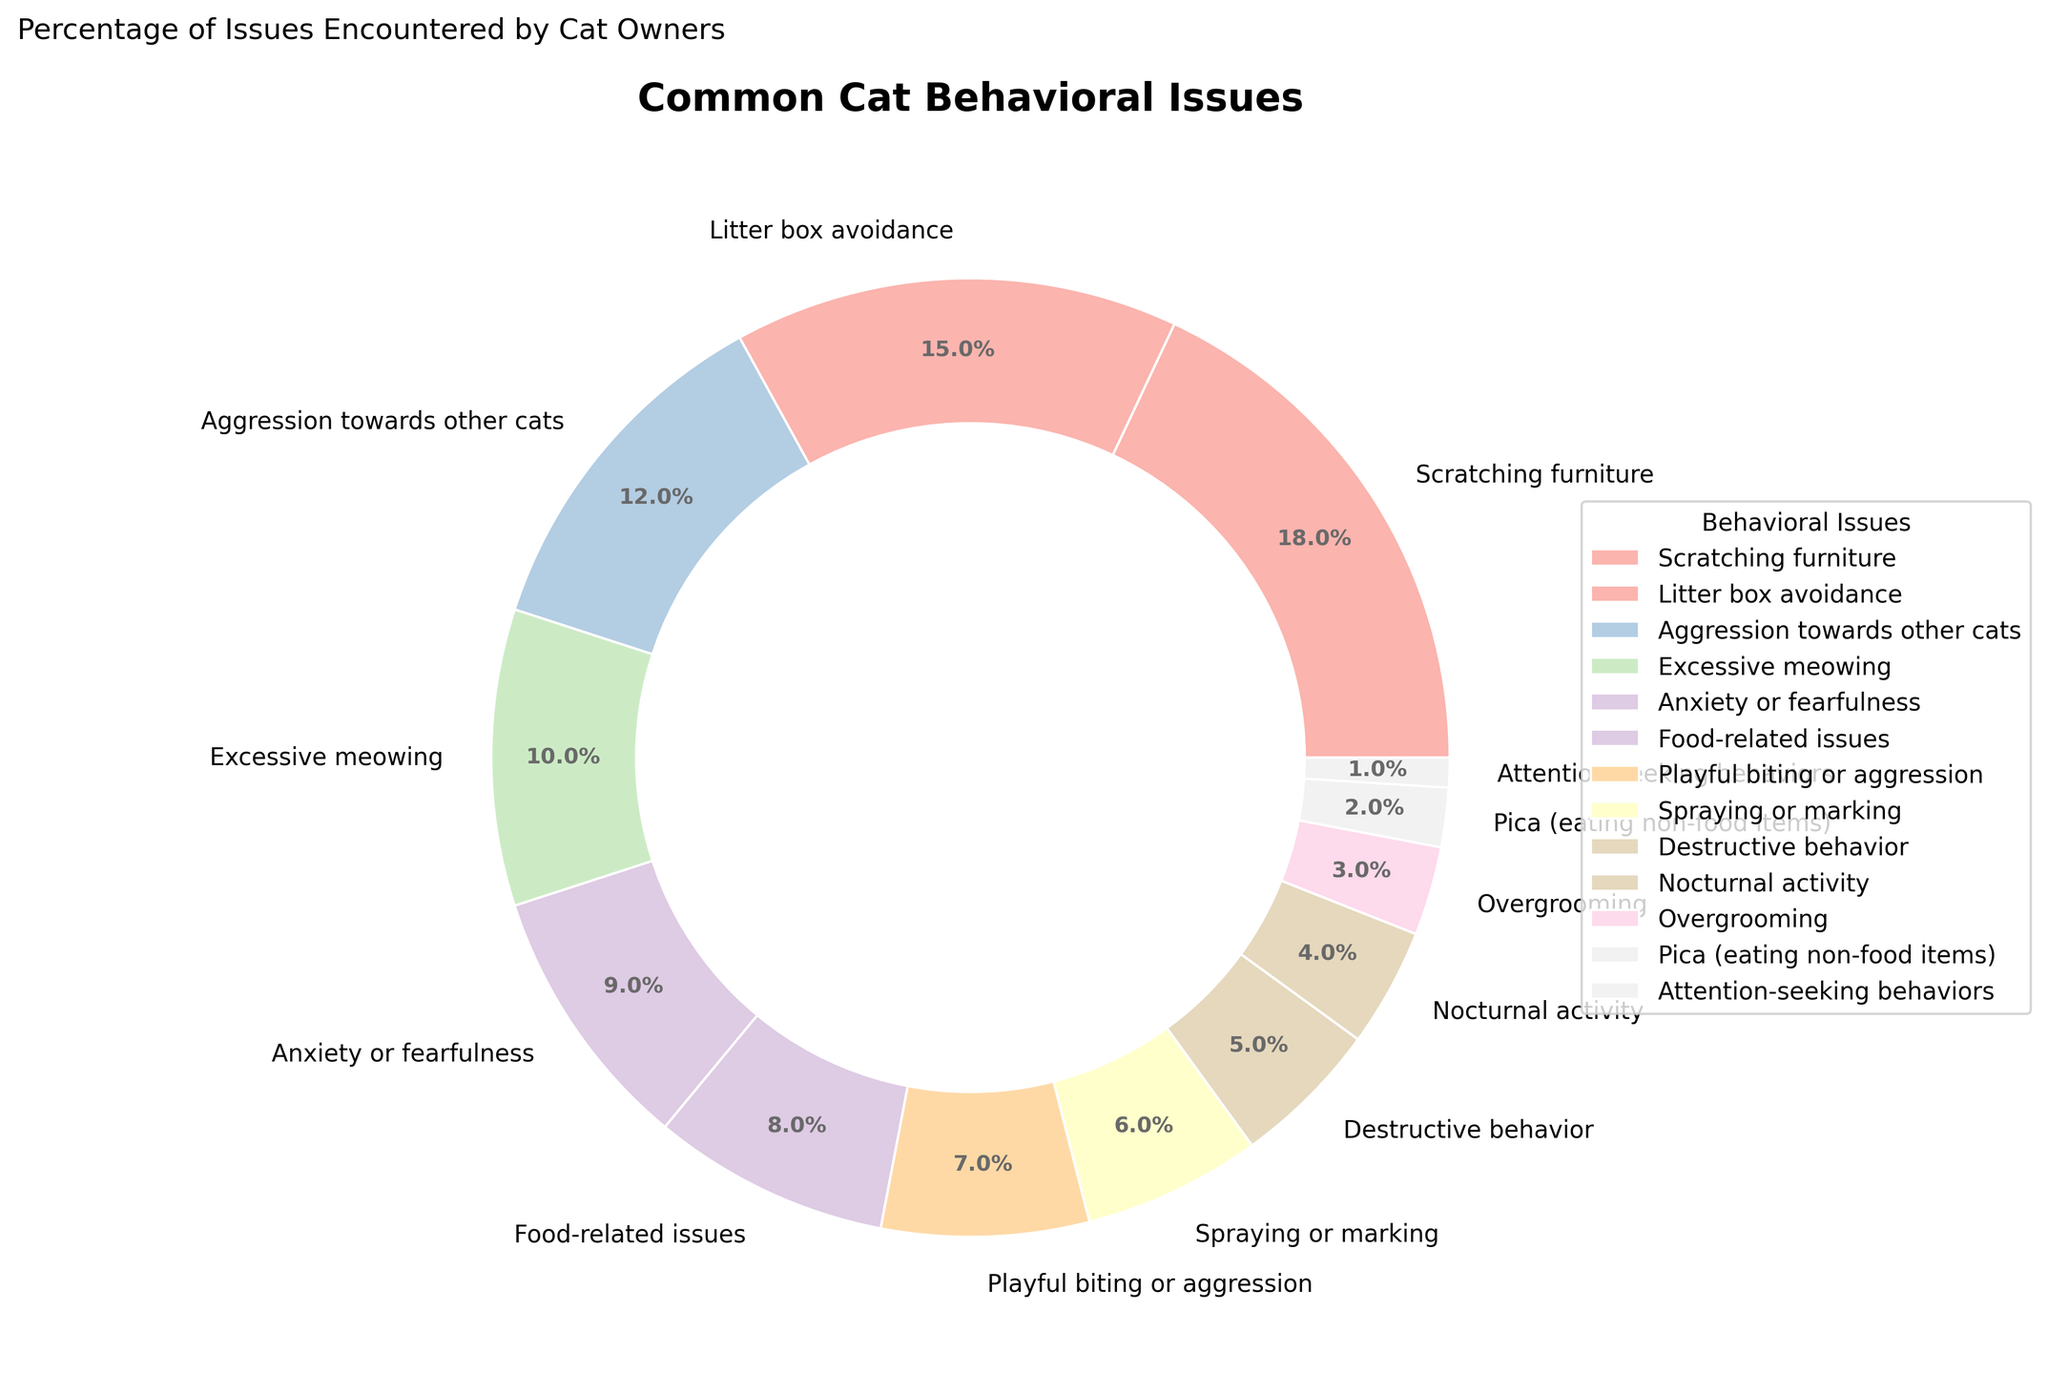What's the most common cat behavioral issue? The most common cat behavioral issue can be identified by looking for the largest segment in the pie chart. From the chart, 'Scratching furniture' has the highest percentage at 18%.
Answer: Scratching furniture Which behavioral issue has a higher percentage: 'Excessive meowing' or 'Aggression towards other cats'? To answer this, compare the two percentages. 'Excessive meowing' is 10% while 'Aggression towards other cats' is 12%.
Answer: Aggression towards other cats What is the combined percentage of 'Pica (eating non-food items)' and 'Attention-seeking behaviors'? Sum the percentages of 'Pica (eating non-food items)' (2%) and 'Attention-seeking behaviors' (1%). Therefore, 2% + 1% = 3%.
Answer: 3% How many behavioral issues have a percentage greater than 10%? We need to count issues with percentages over 10%. These are 'Scratching furniture' (18%), 'Litter box avoidance' (15%), and 'Aggression towards other cats' (12%). There are 3 in total.
Answer: 3 Is the percentage of 'Litter box avoidance' more than twice that of 'Nocturnal activity'? First calculate twice the percentage of 'Nocturnal activity': 2 * 4% = 8%. 'Litter box avoidance' is 15%, which is indeed more than 8%.
Answer: Yes Which color represents 'Playful biting or aggression'? Look at the pie chart segments and the corresponding legend to find 'Playful biting or aggression'. It is represented by one of the pastel colors.
Answer: (Color will vary with the palette but should be described based on the visual chart) What's the difference in percentage between 'Food-related issues' and 'Anxiety or fearfulness'? Subtract the percentage of 'Anxiety or fearfulness' (9%) from 'Food-related issues' (8%). The result is
Answer: 1% Which issues together make up more than 30%? Sum percentages to find combinations over 30%. 'Scratching furniture' (18%), 'Litter box avoidance' (15%) together make 33%. This meets the condition.
Answer: Scratching furniture and Litter box avoidance If 'Excessive meowing' and 'Anxiety or fearfulness' were combined into one category, what percentage would that be? Add the two percentages: 'Excessive meowing' (10%) + 'Anxiety or fearfulness' (9%) = 19%.
Answer: 19% Is 'Spraying or marking' more common than 'Nocturnal activity' and 'Overgrooming' combined? Calculate the combined percentage of 'Nocturnal activity' (4%) and 'Overgrooming' (3%): 4% + 3% = 7%. Compare with 'Spraying or marking' (6%). 7% is greater than 6%.
Answer: No 